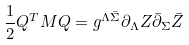<formula> <loc_0><loc_0><loc_500><loc_500>\frac { 1 } { 2 } Q ^ { T } M Q = g ^ { \Lambda \bar { \Sigma } } \partial _ { \Lambda } Z \bar { \partial } _ { \Sigma } \bar { Z }</formula> 